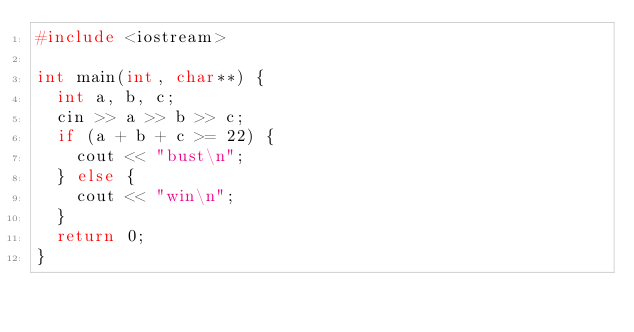<code> <loc_0><loc_0><loc_500><loc_500><_C++_>#include <iostream>

int main(int, char**) {
  int a, b, c;
  cin >> a >> b >> c;
  if (a + b + c >= 22) {
    cout << "bust\n";
  } else {
    cout << "win\n";
  }
  return 0;
}</code> 